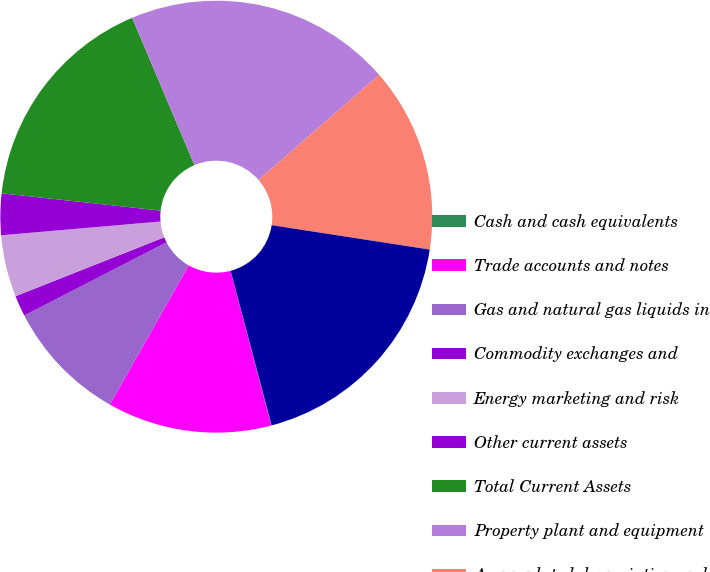<chart> <loc_0><loc_0><loc_500><loc_500><pie_chart><fcel>Cash and cash equivalents<fcel>Trade accounts and notes<fcel>Gas and natural gas liquids in<fcel>Commodity exchanges and<fcel>Energy marketing and risk<fcel>Other current assets<fcel>Total Current Assets<fcel>Property plant and equipment<fcel>Accumulated depreciation and<fcel>Net Property Plant and<nl><fcel>0.03%<fcel>12.3%<fcel>9.23%<fcel>1.56%<fcel>4.63%<fcel>3.1%<fcel>16.9%<fcel>19.97%<fcel>13.84%<fcel>18.44%<nl></chart> 